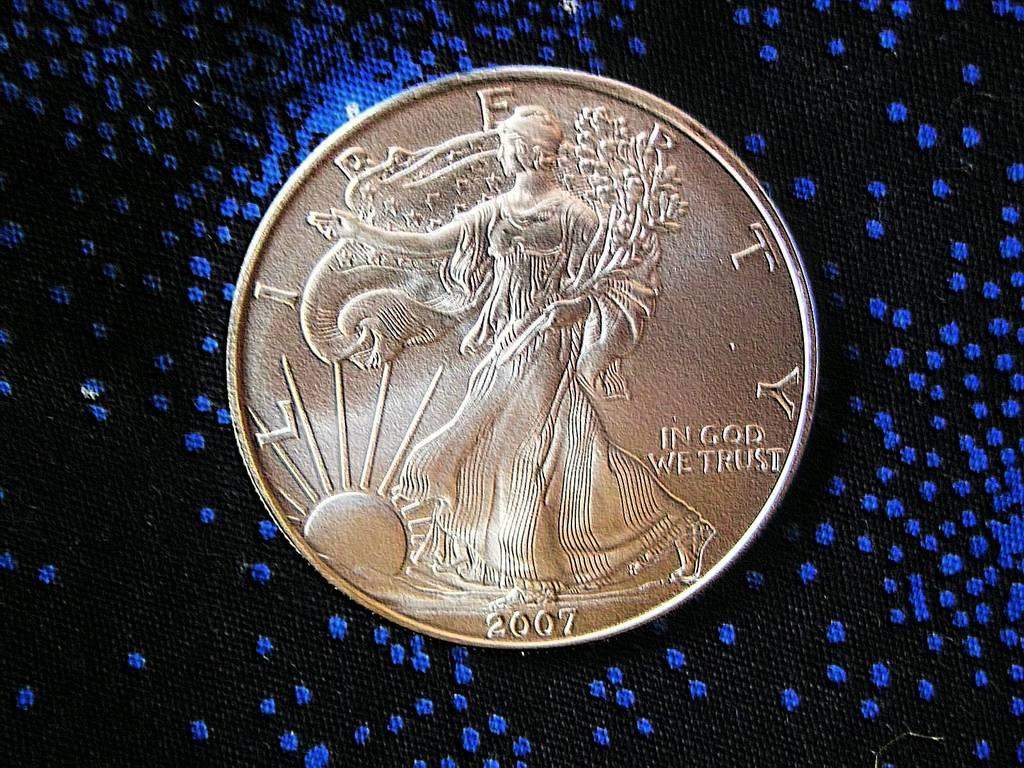<image>
Write a terse but informative summary of the picture. A coin with the word "In God we trust" on it. 